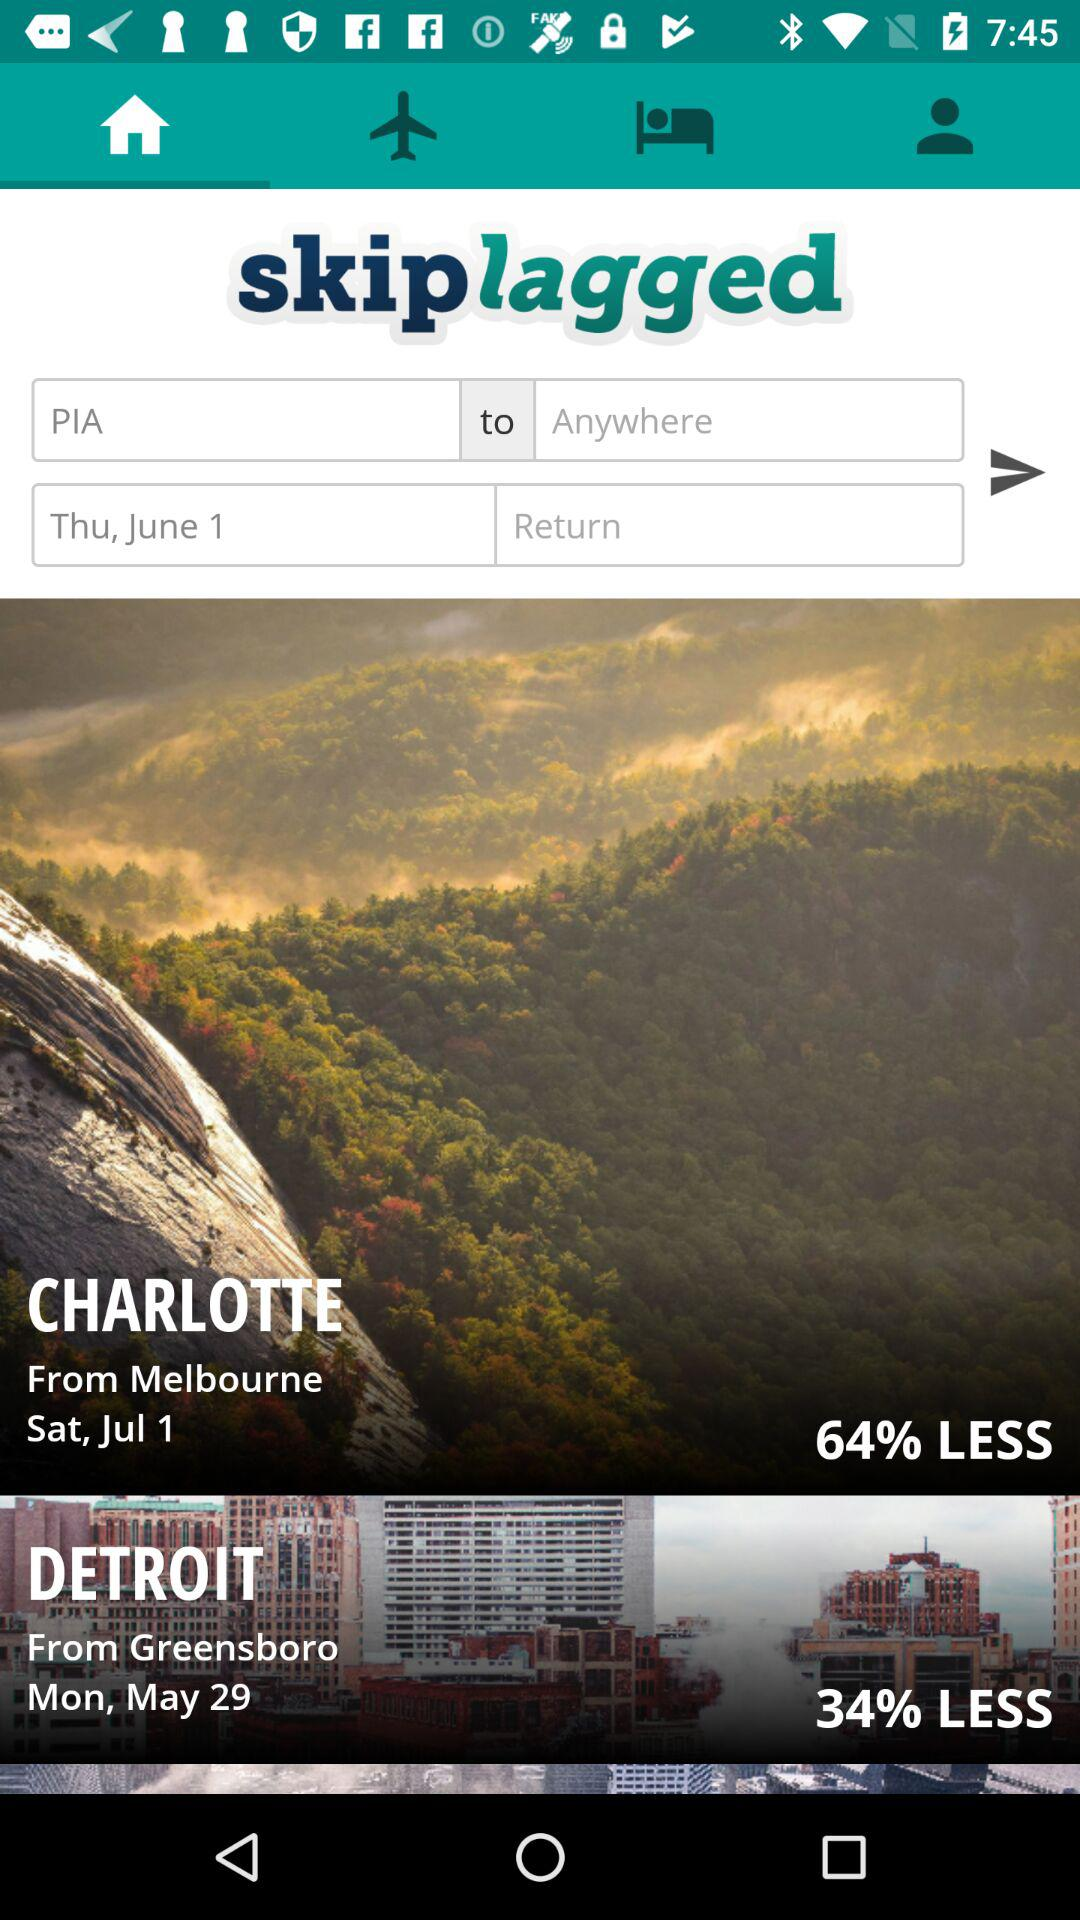What day is it on the selected date? The day is Thursday. 